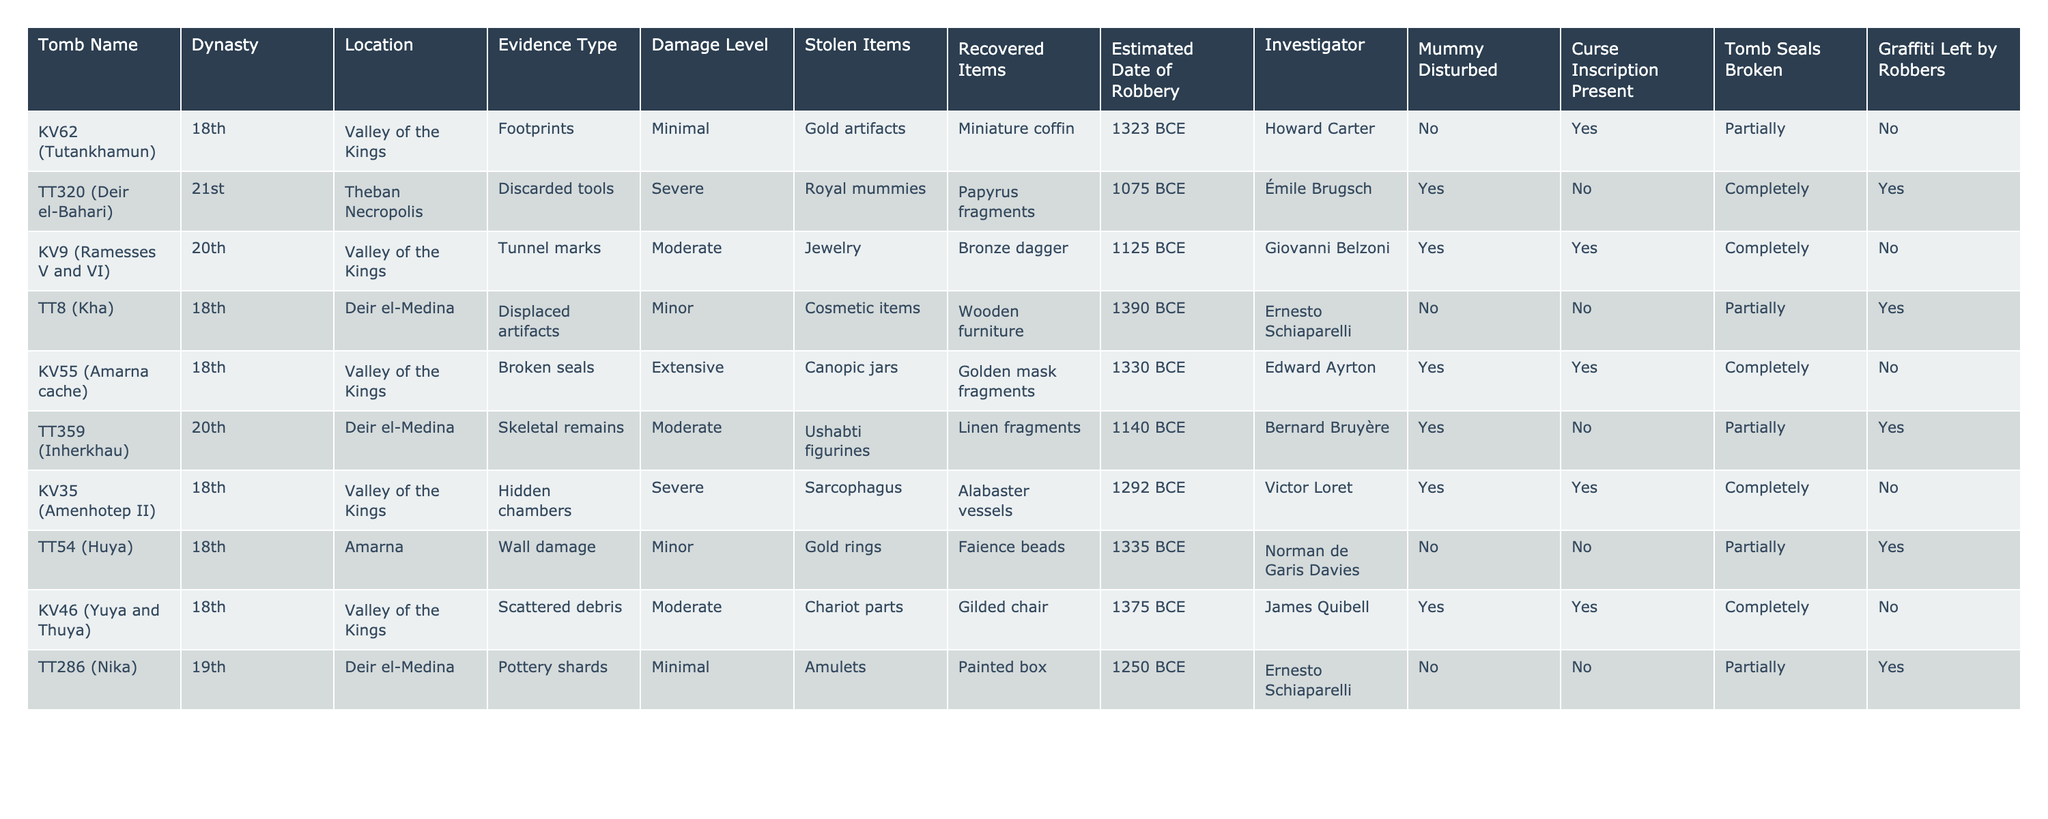What tomb had the most extensive damage level according to the table? The damage level for KV55 (Amarna cache) is labeled as "Extensive," which is higher than any other tomb listed.
Answer: KV55 (Amarna cache) How many tombs had their mummy disturbed during the robbery? By counting the entries, I find that 5 out of the 8 tombs listed have the mummy disturbed.
Answer: 5 Which stolen items were recovered from KV62? The table shows that a miniature coffin was recovered from KV62, while gold artifacts were stolen.
Answer: Miniature coffin What is the latest estimated date of robbery indicated in the table? Scanning the dates, the latest robbery occurred in 1075 BCE, which corresponds to TT320 (Deir el-Bahari).
Answer: 1075 BCE Which tombs have graffiti left by robbers? The tombs with graffiti left by robbers are TT320, TT359, and TT286, confirming that these tombs had this evidence type present.
Answer: TT320, TT359, TT286 Are there any tombs that have broken seals and also had their mummy disturbed? By cross-referencing the entries, KV55 and KV9 confirm that they both have broken seals and have mummy disturbances.
Answer: KV55, KV9 What percentage of the tombs in the table show severe damage? The table displays 3 out of 8 tombs that have severe damage levels. Thus, the percentage is (3/8) * 100 = 37.5%.
Answer: 37.5% How many tombs are located in the Valley of the Kings? By reviewing the locations, there are 5 tombs (KV62, KV9, KV35, KV46, KV55) in the Valley of the Kings.
Answer: 5 Which tomb has the inscription of a curse present but did not disturb the mummy? The simplest evaluation reveals that KV62 shows a curse inscription but the mummy was not disturbed.
Answer: KV62 What is the relationship between damaged tombs and the type of evidence found? Analyzing the rows, the severe damage level often corresponds to found evidence of discarded tools, footprints, or tunnel marks, which indicates a clear link between the severity of damage and evidence types.
Answer: Severe damage often relates to significant evidence types 